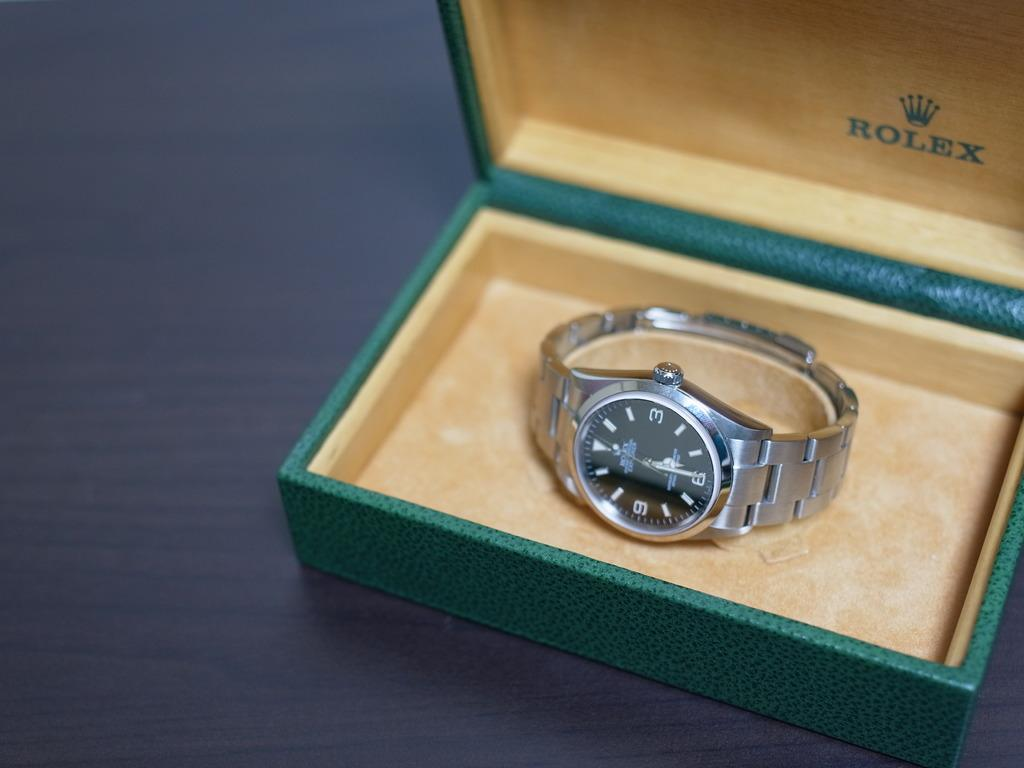<image>
Write a terse but informative summary of the picture. A Rolex watch sits in a green and tan box. 